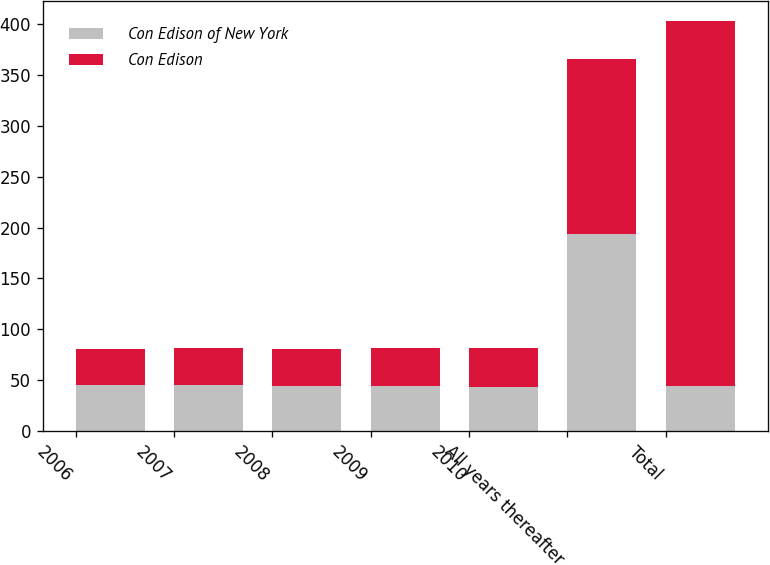Convert chart to OTSL. <chart><loc_0><loc_0><loc_500><loc_500><stacked_bar_chart><ecel><fcel>2006<fcel>2007<fcel>2008<fcel>2009<fcel>2010<fcel>All years thereafter<fcel>Total<nl><fcel>Con Edison of New York<fcel>45<fcel>45<fcel>44<fcel>44<fcel>43<fcel>194<fcel>44<nl><fcel>Con Edison<fcel>36<fcel>37<fcel>37<fcel>38<fcel>39<fcel>172<fcel>359<nl></chart> 